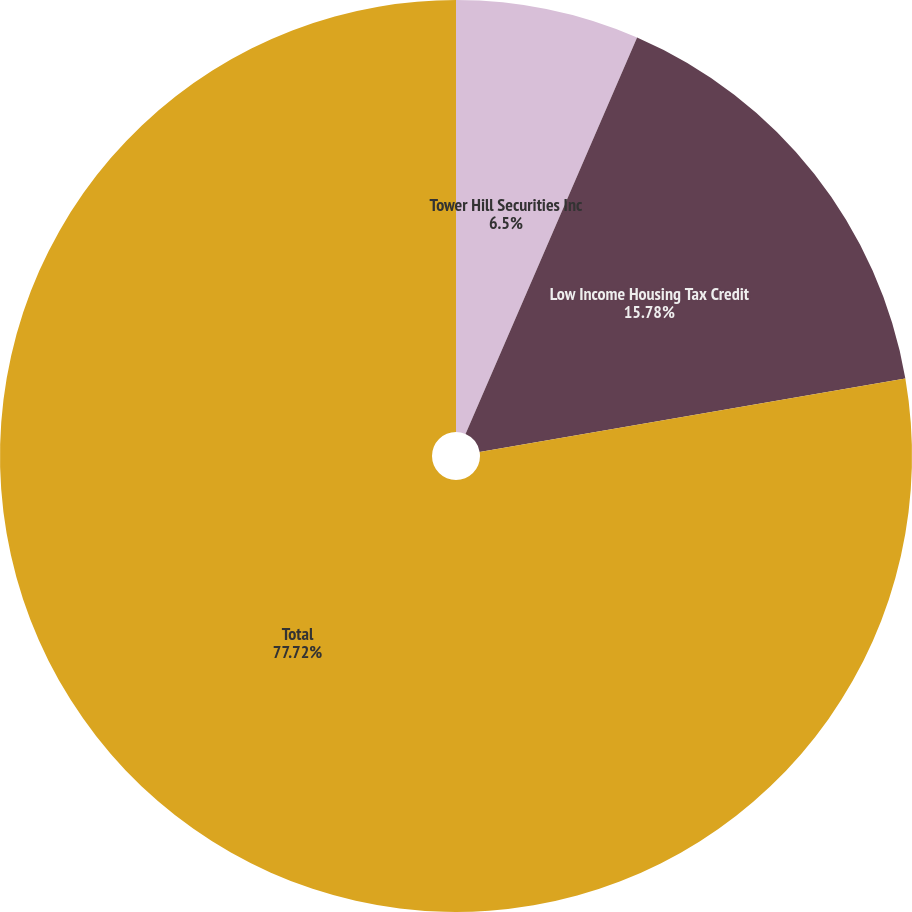Convert chart to OTSL. <chart><loc_0><loc_0><loc_500><loc_500><pie_chart><fcel>Tower Hill Securities Inc<fcel>Low Income Housing Tax Credit<fcel>Total<nl><fcel>6.5%<fcel>15.78%<fcel>77.72%<nl></chart> 